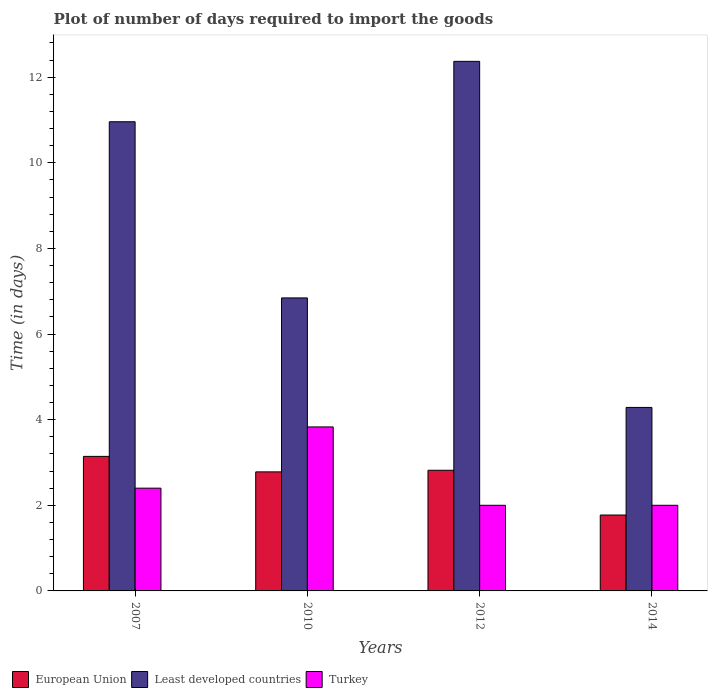Are the number of bars on each tick of the X-axis equal?
Ensure brevity in your answer.  Yes. What is the label of the 1st group of bars from the left?
Your response must be concise. 2007. What is the time required to import goods in Turkey in 2010?
Offer a terse response. 3.83. Across all years, what is the maximum time required to import goods in Least developed countries?
Provide a succinct answer. 12.37. Across all years, what is the minimum time required to import goods in Least developed countries?
Your answer should be compact. 4.29. In which year was the time required to import goods in Least developed countries maximum?
Keep it short and to the point. 2012. What is the total time required to import goods in Least developed countries in the graph?
Offer a very short reply. 34.46. What is the difference between the time required to import goods in Turkey in 2007 and that in 2014?
Ensure brevity in your answer.  0.4. What is the difference between the time required to import goods in Turkey in 2007 and the time required to import goods in European Union in 2014?
Offer a very short reply. 0.63. What is the average time required to import goods in European Union per year?
Provide a short and direct response. 2.63. In the year 2010, what is the difference between the time required to import goods in Least developed countries and time required to import goods in European Union?
Your answer should be very brief. 4.06. In how many years, is the time required to import goods in Turkey greater than 4.8 days?
Your answer should be compact. 0. Is the difference between the time required to import goods in Least developed countries in 2010 and 2012 greater than the difference between the time required to import goods in European Union in 2010 and 2012?
Provide a short and direct response. No. What is the difference between the highest and the second highest time required to import goods in Least developed countries?
Your answer should be very brief. 1.41. What is the difference between the highest and the lowest time required to import goods in Least developed countries?
Offer a very short reply. 8.08. In how many years, is the time required to import goods in Least developed countries greater than the average time required to import goods in Least developed countries taken over all years?
Your answer should be very brief. 2. What does the 2nd bar from the left in 2012 represents?
Give a very brief answer. Least developed countries. Are all the bars in the graph horizontal?
Provide a succinct answer. No. Are the values on the major ticks of Y-axis written in scientific E-notation?
Offer a very short reply. No. Does the graph contain any zero values?
Give a very brief answer. No. Does the graph contain grids?
Your answer should be compact. No. Where does the legend appear in the graph?
Offer a terse response. Bottom left. How many legend labels are there?
Provide a succinct answer. 3. How are the legend labels stacked?
Offer a terse response. Horizontal. What is the title of the graph?
Make the answer very short. Plot of number of days required to import the goods. Does "Namibia" appear as one of the legend labels in the graph?
Give a very brief answer. No. What is the label or title of the Y-axis?
Offer a terse response. Time (in days). What is the Time (in days) in European Union in 2007?
Ensure brevity in your answer.  3.14. What is the Time (in days) of Least developed countries in 2007?
Keep it short and to the point. 10.96. What is the Time (in days) in Turkey in 2007?
Ensure brevity in your answer.  2.4. What is the Time (in days) of European Union in 2010?
Your answer should be very brief. 2.78. What is the Time (in days) in Least developed countries in 2010?
Your answer should be compact. 6.84. What is the Time (in days) in Turkey in 2010?
Make the answer very short. 3.83. What is the Time (in days) in European Union in 2012?
Provide a short and direct response. 2.82. What is the Time (in days) in Least developed countries in 2012?
Provide a succinct answer. 12.37. What is the Time (in days) of Turkey in 2012?
Your answer should be very brief. 2. What is the Time (in days) of European Union in 2014?
Provide a short and direct response. 1.77. What is the Time (in days) of Least developed countries in 2014?
Your response must be concise. 4.29. Across all years, what is the maximum Time (in days) in European Union?
Provide a succinct answer. 3.14. Across all years, what is the maximum Time (in days) of Least developed countries?
Your answer should be compact. 12.37. Across all years, what is the maximum Time (in days) in Turkey?
Your answer should be very brief. 3.83. Across all years, what is the minimum Time (in days) in European Union?
Offer a terse response. 1.77. Across all years, what is the minimum Time (in days) of Least developed countries?
Give a very brief answer. 4.29. Across all years, what is the minimum Time (in days) in Turkey?
Provide a succinct answer. 2. What is the total Time (in days) of European Union in the graph?
Provide a short and direct response. 10.51. What is the total Time (in days) in Least developed countries in the graph?
Give a very brief answer. 34.46. What is the total Time (in days) in Turkey in the graph?
Ensure brevity in your answer.  10.23. What is the difference between the Time (in days) of European Union in 2007 and that in 2010?
Offer a very short reply. 0.36. What is the difference between the Time (in days) in Least developed countries in 2007 and that in 2010?
Provide a short and direct response. 4.11. What is the difference between the Time (in days) of Turkey in 2007 and that in 2010?
Give a very brief answer. -1.43. What is the difference between the Time (in days) in European Union in 2007 and that in 2012?
Make the answer very short. 0.32. What is the difference between the Time (in days) of Least developed countries in 2007 and that in 2012?
Provide a succinct answer. -1.41. What is the difference between the Time (in days) in European Union in 2007 and that in 2014?
Offer a very short reply. 1.37. What is the difference between the Time (in days) in Least developed countries in 2007 and that in 2014?
Your answer should be very brief. 6.67. What is the difference between the Time (in days) in Turkey in 2007 and that in 2014?
Ensure brevity in your answer.  0.4. What is the difference between the Time (in days) in European Union in 2010 and that in 2012?
Ensure brevity in your answer.  -0.04. What is the difference between the Time (in days) in Least developed countries in 2010 and that in 2012?
Your response must be concise. -5.52. What is the difference between the Time (in days) of Turkey in 2010 and that in 2012?
Provide a succinct answer. 1.83. What is the difference between the Time (in days) in European Union in 2010 and that in 2014?
Keep it short and to the point. 1.01. What is the difference between the Time (in days) of Least developed countries in 2010 and that in 2014?
Offer a terse response. 2.56. What is the difference between the Time (in days) of Turkey in 2010 and that in 2014?
Your response must be concise. 1.83. What is the difference between the Time (in days) of European Union in 2012 and that in 2014?
Offer a terse response. 1.05. What is the difference between the Time (in days) of Least developed countries in 2012 and that in 2014?
Your response must be concise. 8.08. What is the difference between the Time (in days) of Turkey in 2012 and that in 2014?
Provide a succinct answer. 0. What is the difference between the Time (in days) of European Union in 2007 and the Time (in days) of Least developed countries in 2010?
Offer a very short reply. -3.7. What is the difference between the Time (in days) in European Union in 2007 and the Time (in days) in Turkey in 2010?
Your answer should be very brief. -0.69. What is the difference between the Time (in days) in Least developed countries in 2007 and the Time (in days) in Turkey in 2010?
Keep it short and to the point. 7.13. What is the difference between the Time (in days) in European Union in 2007 and the Time (in days) in Least developed countries in 2012?
Offer a very short reply. -9.23. What is the difference between the Time (in days) in European Union in 2007 and the Time (in days) in Turkey in 2012?
Provide a short and direct response. 1.14. What is the difference between the Time (in days) in Least developed countries in 2007 and the Time (in days) in Turkey in 2012?
Provide a succinct answer. 8.96. What is the difference between the Time (in days) of European Union in 2007 and the Time (in days) of Least developed countries in 2014?
Provide a succinct answer. -1.14. What is the difference between the Time (in days) in European Union in 2007 and the Time (in days) in Turkey in 2014?
Your response must be concise. 1.14. What is the difference between the Time (in days) in Least developed countries in 2007 and the Time (in days) in Turkey in 2014?
Your answer should be compact. 8.96. What is the difference between the Time (in days) of European Union in 2010 and the Time (in days) of Least developed countries in 2012?
Give a very brief answer. -9.59. What is the difference between the Time (in days) in European Union in 2010 and the Time (in days) in Turkey in 2012?
Provide a short and direct response. 0.78. What is the difference between the Time (in days) in Least developed countries in 2010 and the Time (in days) in Turkey in 2012?
Your answer should be very brief. 4.84. What is the difference between the Time (in days) in European Union in 2010 and the Time (in days) in Least developed countries in 2014?
Keep it short and to the point. -1.51. What is the difference between the Time (in days) of European Union in 2010 and the Time (in days) of Turkey in 2014?
Your response must be concise. 0.78. What is the difference between the Time (in days) of Least developed countries in 2010 and the Time (in days) of Turkey in 2014?
Give a very brief answer. 4.84. What is the difference between the Time (in days) of European Union in 2012 and the Time (in days) of Least developed countries in 2014?
Provide a succinct answer. -1.47. What is the difference between the Time (in days) of European Union in 2012 and the Time (in days) of Turkey in 2014?
Ensure brevity in your answer.  0.82. What is the difference between the Time (in days) of Least developed countries in 2012 and the Time (in days) of Turkey in 2014?
Offer a very short reply. 10.37. What is the average Time (in days) of European Union per year?
Your answer should be very brief. 2.63. What is the average Time (in days) in Least developed countries per year?
Offer a very short reply. 8.61. What is the average Time (in days) of Turkey per year?
Give a very brief answer. 2.56. In the year 2007, what is the difference between the Time (in days) in European Union and Time (in days) in Least developed countries?
Make the answer very short. -7.82. In the year 2007, what is the difference between the Time (in days) of European Union and Time (in days) of Turkey?
Keep it short and to the point. 0.74. In the year 2007, what is the difference between the Time (in days) of Least developed countries and Time (in days) of Turkey?
Your answer should be very brief. 8.56. In the year 2010, what is the difference between the Time (in days) in European Union and Time (in days) in Least developed countries?
Ensure brevity in your answer.  -4.06. In the year 2010, what is the difference between the Time (in days) in European Union and Time (in days) in Turkey?
Offer a very short reply. -1.05. In the year 2010, what is the difference between the Time (in days) in Least developed countries and Time (in days) in Turkey?
Provide a short and direct response. 3.01. In the year 2012, what is the difference between the Time (in days) of European Union and Time (in days) of Least developed countries?
Provide a succinct answer. -9.55. In the year 2012, what is the difference between the Time (in days) in European Union and Time (in days) in Turkey?
Provide a short and direct response. 0.82. In the year 2012, what is the difference between the Time (in days) in Least developed countries and Time (in days) in Turkey?
Provide a short and direct response. 10.37. In the year 2014, what is the difference between the Time (in days) of European Union and Time (in days) of Least developed countries?
Keep it short and to the point. -2.51. In the year 2014, what is the difference between the Time (in days) in European Union and Time (in days) in Turkey?
Your answer should be compact. -0.23. In the year 2014, what is the difference between the Time (in days) of Least developed countries and Time (in days) of Turkey?
Keep it short and to the point. 2.29. What is the ratio of the Time (in days) in European Union in 2007 to that in 2010?
Offer a very short reply. 1.13. What is the ratio of the Time (in days) of Least developed countries in 2007 to that in 2010?
Provide a succinct answer. 1.6. What is the ratio of the Time (in days) of Turkey in 2007 to that in 2010?
Keep it short and to the point. 0.63. What is the ratio of the Time (in days) in European Union in 2007 to that in 2012?
Ensure brevity in your answer.  1.11. What is the ratio of the Time (in days) of Least developed countries in 2007 to that in 2012?
Offer a very short reply. 0.89. What is the ratio of the Time (in days) in European Union in 2007 to that in 2014?
Keep it short and to the point. 1.77. What is the ratio of the Time (in days) of Least developed countries in 2007 to that in 2014?
Offer a very short reply. 2.56. What is the ratio of the Time (in days) of Turkey in 2007 to that in 2014?
Your answer should be very brief. 1.2. What is the ratio of the Time (in days) in European Union in 2010 to that in 2012?
Ensure brevity in your answer.  0.99. What is the ratio of the Time (in days) of Least developed countries in 2010 to that in 2012?
Make the answer very short. 0.55. What is the ratio of the Time (in days) in Turkey in 2010 to that in 2012?
Give a very brief answer. 1.92. What is the ratio of the Time (in days) of European Union in 2010 to that in 2014?
Provide a short and direct response. 1.57. What is the ratio of the Time (in days) in Least developed countries in 2010 to that in 2014?
Provide a succinct answer. 1.6. What is the ratio of the Time (in days) in Turkey in 2010 to that in 2014?
Provide a succinct answer. 1.92. What is the ratio of the Time (in days) in European Union in 2012 to that in 2014?
Keep it short and to the point. 1.59. What is the ratio of the Time (in days) of Least developed countries in 2012 to that in 2014?
Ensure brevity in your answer.  2.89. What is the ratio of the Time (in days) in Turkey in 2012 to that in 2014?
Give a very brief answer. 1. What is the difference between the highest and the second highest Time (in days) of European Union?
Make the answer very short. 0.32. What is the difference between the highest and the second highest Time (in days) in Least developed countries?
Ensure brevity in your answer.  1.41. What is the difference between the highest and the second highest Time (in days) of Turkey?
Your answer should be compact. 1.43. What is the difference between the highest and the lowest Time (in days) in European Union?
Your response must be concise. 1.37. What is the difference between the highest and the lowest Time (in days) in Least developed countries?
Give a very brief answer. 8.08. What is the difference between the highest and the lowest Time (in days) of Turkey?
Offer a very short reply. 1.83. 